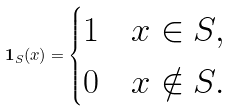<formula> <loc_0><loc_0><loc_500><loc_500>\mathbf 1 _ { S } ( x ) = \begin{cases} 1 \quad x \in S , \\ 0 \quad x \notin S . \end{cases}</formula> 